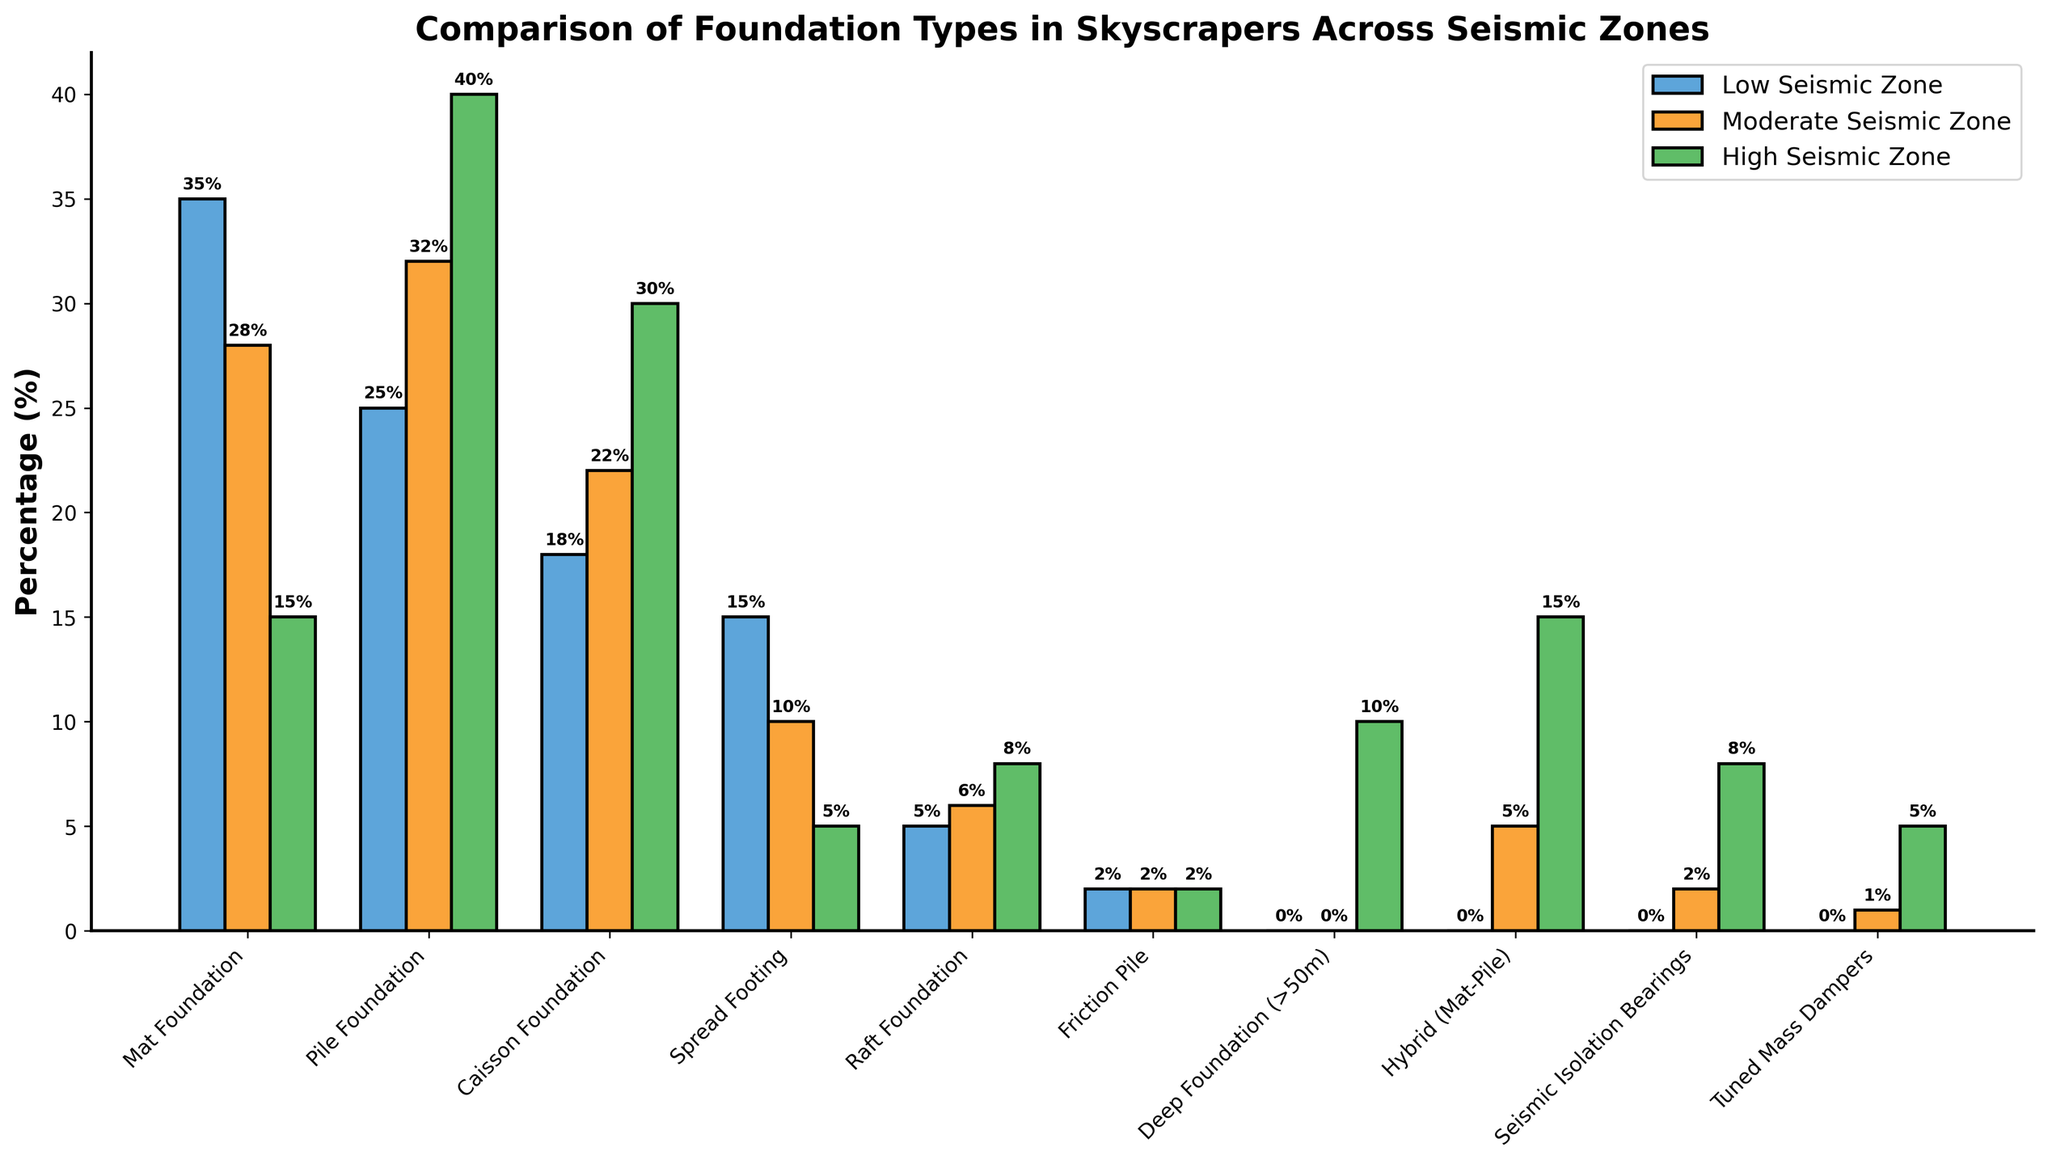Which foundation type is most frequently used in high seismic zones? The tallest bar in the "High Seismic Zone" section represents the most frequently used foundation type. The "Pile Foundation" bar is the tallest, indicating it is the most frequently used.
Answer: Pile Foundation Which foundation type shows the least variation in usage across all seismic zones? The foundation type with bars of nearly equal height in all three seismic zones shows the least variation. Friction Pile shows bars of equal height (2) in all regions.
Answer: Friction Pile How does the usage of Mat Foundation in low seismic zones compare to high seismic zones? Compare the heights of the "Mat Foundation" bars in the "Low Seismic Zone" and "High Seismic Zone". The bar in the low seismic zone is 35, and in the high seismic zone, it is 15.
Answer: Higher in low seismic zones What is the total percentage of skyscrapers using Spread Footing in all seismic zones? Sum the heights of the "Spread Footing" bars across all seismic zones: 15 (low) + 10 (moderate) + 5 (high). The total is 30.
Answer: 30% Which seismic zone has the highest usage of Caisson Foundation? Identify the tallest bar in the "Caisson Foundation" category. The bar for the high seismic zone is 30, the tallest compared to the other zones.
Answer: High seismic zone Compare the usage of Raft Foundation in low seismic zones with its usage in moderate seismic zones. Which is higher? Compare the heights of the "Raft Foundation" bars in the low and moderate seismic zones. The height in the low seismic zone is 5, and in the moderate seismic zone, it is 6.
Answer: Moderate seismic zones What is the average usage of the "Hybrid (Mat-Pile)" foundation across all seismic zones? Calculate the average by summing the heights of the bars in all seismic zones and dividing by three: (0 + 5 + 15) / 3 = 20 / 3 ≈ 6.67.
Answer: 6.67% Are Seismic Isolation Bearings more used in high or moderate seismic zones? Compare the heights of the bars for "Seismic Isolation Bearings" in the high and moderate seismic zones. The height in the high seismic zone is 8, and in the moderate seismic zone, it is 2.
Answer: High seismic zones What is the difference in usage between Mat Foundation and Pile Foundation in moderate seismic zones? Subtract the height of the "Mat Foundation" bar from the "Pile Foundation" bar in the moderate seismic zone. The "Pile Foundation" bar is 32, and the "Mat Foundation" bar is 28. 32 - 28 = 4.
Answer: 4 Which foundation type is least used in moderate seismic zones? Identify the shortest bar or bars in the "Moderate Seismic Zone". The "Friction Pile" bar is the shortest, with a height of 2.
Answer: Friction Pile 